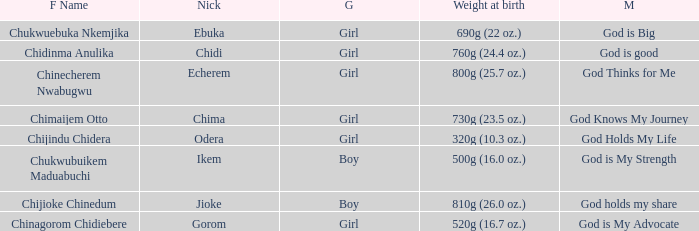Parse the full table. {'header': ['F Name', 'Nick', 'G', 'Weight at birth', 'M'], 'rows': [['Chukwuebuka Nkemjika', 'Ebuka', 'Girl', '690g (22 oz.)', 'God is Big'], ['Chidinma Anulika', 'Chidi', 'Girl', '760g (24.4 oz.)', 'God is good'], ['Chinecherem Nwabugwu', 'Echerem', 'Girl', '800g (25.7 oz.)', 'God Thinks for Me'], ['Chimaijem Otto', 'Chima', 'Girl', '730g (23.5 oz.)', 'God Knows My Journey'], ['Chijindu Chidera', 'Odera', 'Girl', '320g (10.3 oz.)', 'God Holds My Life'], ['Chukwubuikem Maduabuchi', 'Ikem', 'Boy', '500g (16.0 oz.)', 'God is My Strength'], ['Chijioke Chinedum', 'Jioke', 'Boy', '810g (26.0 oz.)', 'God holds my share'], ['Chinagorom Chidiebere', 'Gorom', 'Girl', '520g (16.7 oz.)', 'God is My Advocate']]} How much did the baby who name means God knows my journey weigh at birth? 730g (23.5 oz.). 